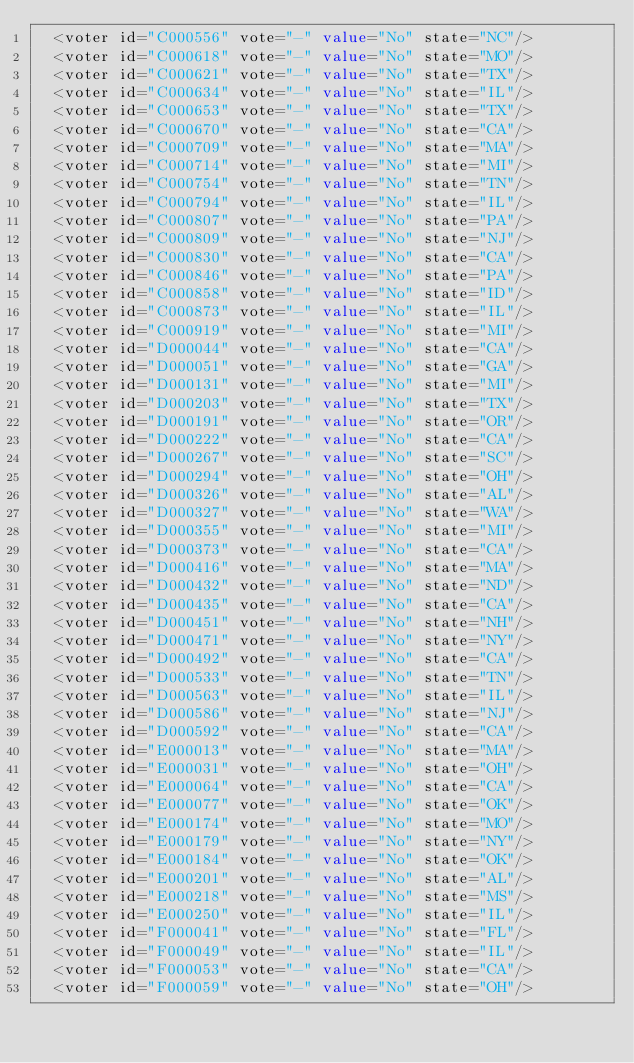Convert code to text. <code><loc_0><loc_0><loc_500><loc_500><_XML_>  <voter id="C000556" vote="-" value="No" state="NC"/>
  <voter id="C000618" vote="-" value="No" state="MO"/>
  <voter id="C000621" vote="-" value="No" state="TX"/>
  <voter id="C000634" vote="-" value="No" state="IL"/>
  <voter id="C000653" vote="-" value="No" state="TX"/>
  <voter id="C000670" vote="-" value="No" state="CA"/>
  <voter id="C000709" vote="-" value="No" state="MA"/>
  <voter id="C000714" vote="-" value="No" state="MI"/>
  <voter id="C000754" vote="-" value="No" state="TN"/>
  <voter id="C000794" vote="-" value="No" state="IL"/>
  <voter id="C000807" vote="-" value="No" state="PA"/>
  <voter id="C000809" vote="-" value="No" state="NJ"/>
  <voter id="C000830" vote="-" value="No" state="CA"/>
  <voter id="C000846" vote="-" value="No" state="PA"/>
  <voter id="C000858" vote="-" value="No" state="ID"/>
  <voter id="C000873" vote="-" value="No" state="IL"/>
  <voter id="C000919" vote="-" value="No" state="MI"/>
  <voter id="D000044" vote="-" value="No" state="CA"/>
  <voter id="D000051" vote="-" value="No" state="GA"/>
  <voter id="D000131" vote="-" value="No" state="MI"/>
  <voter id="D000203" vote="-" value="No" state="TX"/>
  <voter id="D000191" vote="-" value="No" state="OR"/>
  <voter id="D000222" vote="-" value="No" state="CA"/>
  <voter id="D000267" vote="-" value="No" state="SC"/>
  <voter id="D000294" vote="-" value="No" state="OH"/>
  <voter id="D000326" vote="-" value="No" state="AL"/>
  <voter id="D000327" vote="-" value="No" state="WA"/>
  <voter id="D000355" vote="-" value="No" state="MI"/>
  <voter id="D000373" vote="-" value="No" state="CA"/>
  <voter id="D000416" vote="-" value="No" state="MA"/>
  <voter id="D000432" vote="-" value="No" state="ND"/>
  <voter id="D000435" vote="-" value="No" state="CA"/>
  <voter id="D000451" vote="-" value="No" state="NH"/>
  <voter id="D000471" vote="-" value="No" state="NY"/>
  <voter id="D000492" vote="-" value="No" state="CA"/>
  <voter id="D000533" vote="-" value="No" state="TN"/>
  <voter id="D000563" vote="-" value="No" state="IL"/>
  <voter id="D000586" vote="-" value="No" state="NJ"/>
  <voter id="D000592" vote="-" value="No" state="CA"/>
  <voter id="E000013" vote="-" value="No" state="MA"/>
  <voter id="E000031" vote="-" value="No" state="OH"/>
  <voter id="E000064" vote="-" value="No" state="CA"/>
  <voter id="E000077" vote="-" value="No" state="OK"/>
  <voter id="E000174" vote="-" value="No" state="MO"/>
  <voter id="E000179" vote="-" value="No" state="NY"/>
  <voter id="E000184" vote="-" value="No" state="OK"/>
  <voter id="E000201" vote="-" value="No" state="AL"/>
  <voter id="E000218" vote="-" value="No" state="MS"/>
  <voter id="E000250" vote="-" value="No" state="IL"/>
  <voter id="F000041" vote="-" value="No" state="FL"/>
  <voter id="F000049" vote="-" value="No" state="IL"/>
  <voter id="F000053" vote="-" value="No" state="CA"/>
  <voter id="F000059" vote="-" value="No" state="OH"/></code> 